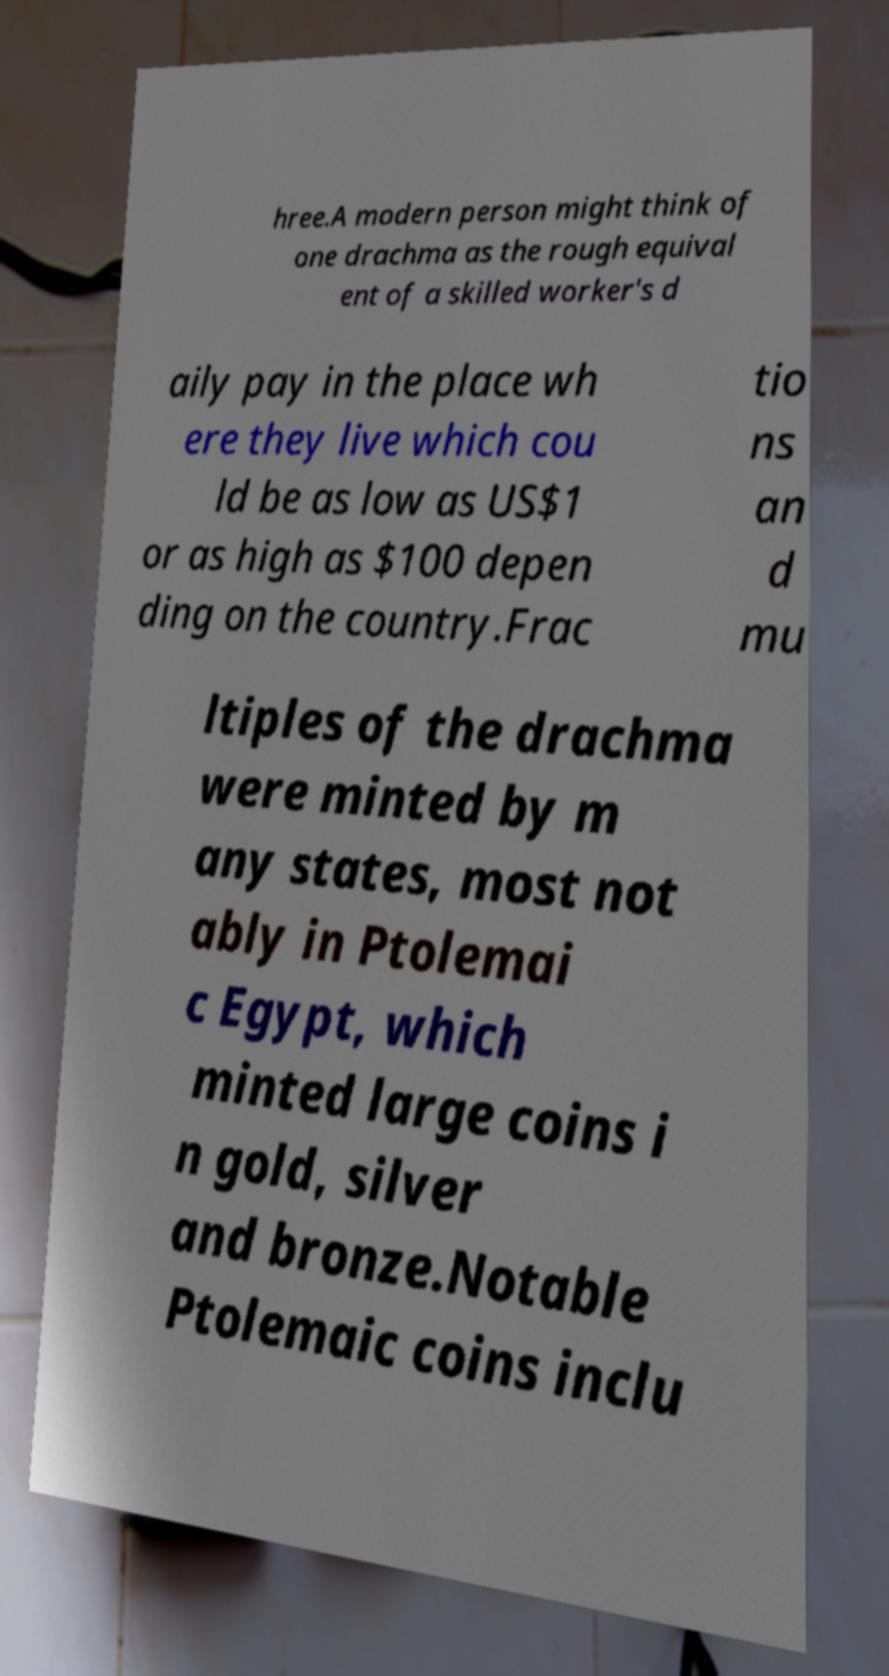There's text embedded in this image that I need extracted. Can you transcribe it verbatim? hree.A modern person might think of one drachma as the rough equival ent of a skilled worker's d aily pay in the place wh ere they live which cou ld be as low as US$1 or as high as $100 depen ding on the country.Frac tio ns an d mu ltiples of the drachma were minted by m any states, most not ably in Ptolemai c Egypt, which minted large coins i n gold, silver and bronze.Notable Ptolemaic coins inclu 